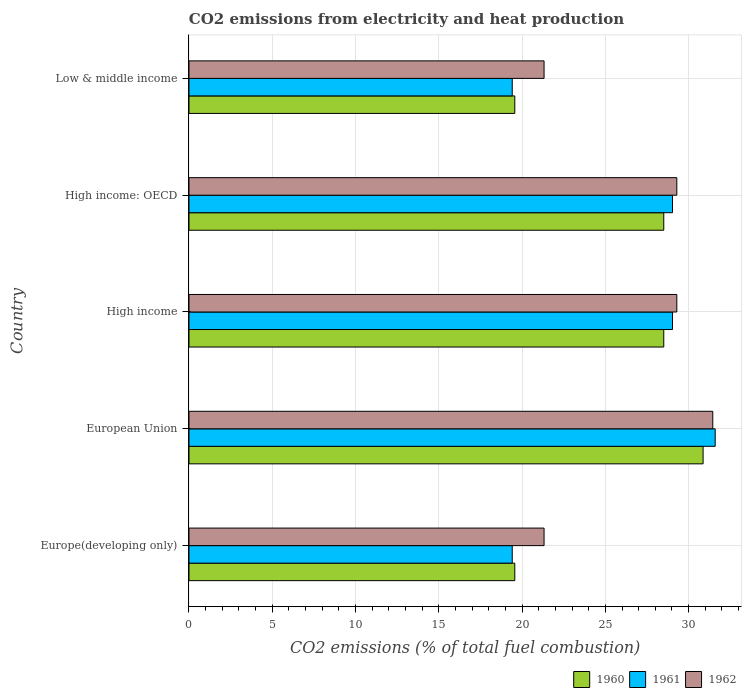How many different coloured bars are there?
Offer a terse response. 3. What is the amount of CO2 emitted in 1961 in Low & middle income?
Ensure brevity in your answer.  19.41. Across all countries, what is the maximum amount of CO2 emitted in 1962?
Ensure brevity in your answer.  31.45. Across all countries, what is the minimum amount of CO2 emitted in 1960?
Make the answer very short. 19.56. In which country was the amount of CO2 emitted in 1961 minimum?
Your answer should be compact. Europe(developing only). What is the total amount of CO2 emitted in 1961 in the graph?
Offer a terse response. 128.48. What is the difference between the amount of CO2 emitted in 1962 in European Union and that in High income: OECD?
Ensure brevity in your answer.  2.16. What is the difference between the amount of CO2 emitted in 1960 in European Union and the amount of CO2 emitted in 1962 in High income?
Offer a terse response. 1.58. What is the average amount of CO2 emitted in 1961 per country?
Your response must be concise. 25.7. What is the difference between the amount of CO2 emitted in 1960 and amount of CO2 emitted in 1962 in High income: OECD?
Make the answer very short. -0.78. What is the ratio of the amount of CO2 emitted in 1962 in European Union to that in High income: OECD?
Your response must be concise. 1.07. What is the difference between the highest and the second highest amount of CO2 emitted in 1960?
Offer a terse response. 2.36. What is the difference between the highest and the lowest amount of CO2 emitted in 1962?
Ensure brevity in your answer.  10.13. Is the sum of the amount of CO2 emitted in 1962 in Europe(developing only) and European Union greater than the maximum amount of CO2 emitted in 1960 across all countries?
Provide a succinct answer. Yes. Is it the case that in every country, the sum of the amount of CO2 emitted in 1962 and amount of CO2 emitted in 1960 is greater than the amount of CO2 emitted in 1961?
Your answer should be very brief. Yes. How many bars are there?
Ensure brevity in your answer.  15. Are all the bars in the graph horizontal?
Provide a short and direct response. Yes. How many countries are there in the graph?
Keep it short and to the point. 5. Does the graph contain any zero values?
Your response must be concise. No. Does the graph contain grids?
Your answer should be very brief. Yes. How are the legend labels stacked?
Ensure brevity in your answer.  Horizontal. What is the title of the graph?
Provide a short and direct response. CO2 emissions from electricity and heat production. Does "1965" appear as one of the legend labels in the graph?
Make the answer very short. No. What is the label or title of the X-axis?
Offer a very short reply. CO2 emissions (% of total fuel combustion). What is the label or title of the Y-axis?
Offer a terse response. Country. What is the CO2 emissions (% of total fuel combustion) of 1960 in Europe(developing only)?
Your response must be concise. 19.56. What is the CO2 emissions (% of total fuel combustion) in 1961 in Europe(developing only)?
Make the answer very short. 19.41. What is the CO2 emissions (% of total fuel combustion) in 1962 in Europe(developing only)?
Your answer should be compact. 21.32. What is the CO2 emissions (% of total fuel combustion) of 1960 in European Union?
Provide a succinct answer. 30.87. What is the CO2 emissions (% of total fuel combustion) in 1961 in European Union?
Your answer should be very brief. 31.59. What is the CO2 emissions (% of total fuel combustion) of 1962 in European Union?
Your answer should be compact. 31.45. What is the CO2 emissions (% of total fuel combustion) in 1960 in High income?
Ensure brevity in your answer.  28.51. What is the CO2 emissions (% of total fuel combustion) in 1961 in High income?
Provide a succinct answer. 29.03. What is the CO2 emissions (% of total fuel combustion) of 1962 in High income?
Provide a succinct answer. 29.29. What is the CO2 emissions (% of total fuel combustion) of 1960 in High income: OECD?
Your answer should be very brief. 28.51. What is the CO2 emissions (% of total fuel combustion) of 1961 in High income: OECD?
Ensure brevity in your answer.  29.03. What is the CO2 emissions (% of total fuel combustion) of 1962 in High income: OECD?
Your answer should be compact. 29.29. What is the CO2 emissions (% of total fuel combustion) of 1960 in Low & middle income?
Your answer should be compact. 19.56. What is the CO2 emissions (% of total fuel combustion) in 1961 in Low & middle income?
Your answer should be very brief. 19.41. What is the CO2 emissions (% of total fuel combustion) in 1962 in Low & middle income?
Your response must be concise. 21.32. Across all countries, what is the maximum CO2 emissions (% of total fuel combustion) in 1960?
Your answer should be compact. 30.87. Across all countries, what is the maximum CO2 emissions (% of total fuel combustion) of 1961?
Offer a very short reply. 31.59. Across all countries, what is the maximum CO2 emissions (% of total fuel combustion) of 1962?
Keep it short and to the point. 31.45. Across all countries, what is the minimum CO2 emissions (% of total fuel combustion) in 1960?
Offer a terse response. 19.56. Across all countries, what is the minimum CO2 emissions (% of total fuel combustion) in 1961?
Provide a succinct answer. 19.41. Across all countries, what is the minimum CO2 emissions (% of total fuel combustion) of 1962?
Your answer should be compact. 21.32. What is the total CO2 emissions (% of total fuel combustion) in 1960 in the graph?
Ensure brevity in your answer.  127.01. What is the total CO2 emissions (% of total fuel combustion) of 1961 in the graph?
Your response must be concise. 128.48. What is the total CO2 emissions (% of total fuel combustion) of 1962 in the graph?
Ensure brevity in your answer.  132.67. What is the difference between the CO2 emissions (% of total fuel combustion) of 1960 in Europe(developing only) and that in European Union?
Your answer should be compact. -11.31. What is the difference between the CO2 emissions (% of total fuel combustion) in 1961 in Europe(developing only) and that in European Union?
Ensure brevity in your answer.  -12.19. What is the difference between the CO2 emissions (% of total fuel combustion) in 1962 in Europe(developing only) and that in European Union?
Offer a terse response. -10.13. What is the difference between the CO2 emissions (% of total fuel combustion) in 1960 in Europe(developing only) and that in High income?
Keep it short and to the point. -8.94. What is the difference between the CO2 emissions (% of total fuel combustion) in 1961 in Europe(developing only) and that in High income?
Offer a terse response. -9.62. What is the difference between the CO2 emissions (% of total fuel combustion) of 1962 in Europe(developing only) and that in High income?
Your answer should be compact. -7.97. What is the difference between the CO2 emissions (% of total fuel combustion) in 1960 in Europe(developing only) and that in High income: OECD?
Ensure brevity in your answer.  -8.94. What is the difference between the CO2 emissions (% of total fuel combustion) in 1961 in Europe(developing only) and that in High income: OECD?
Ensure brevity in your answer.  -9.62. What is the difference between the CO2 emissions (% of total fuel combustion) of 1962 in Europe(developing only) and that in High income: OECD?
Keep it short and to the point. -7.97. What is the difference between the CO2 emissions (% of total fuel combustion) of 1960 in Europe(developing only) and that in Low & middle income?
Offer a very short reply. 0. What is the difference between the CO2 emissions (% of total fuel combustion) of 1961 in Europe(developing only) and that in Low & middle income?
Ensure brevity in your answer.  0. What is the difference between the CO2 emissions (% of total fuel combustion) of 1962 in Europe(developing only) and that in Low & middle income?
Provide a succinct answer. 0. What is the difference between the CO2 emissions (% of total fuel combustion) in 1960 in European Union and that in High income?
Offer a very short reply. 2.36. What is the difference between the CO2 emissions (% of total fuel combustion) in 1961 in European Union and that in High income?
Ensure brevity in your answer.  2.56. What is the difference between the CO2 emissions (% of total fuel combustion) of 1962 in European Union and that in High income?
Make the answer very short. 2.16. What is the difference between the CO2 emissions (% of total fuel combustion) in 1960 in European Union and that in High income: OECD?
Your answer should be very brief. 2.36. What is the difference between the CO2 emissions (% of total fuel combustion) of 1961 in European Union and that in High income: OECD?
Offer a very short reply. 2.56. What is the difference between the CO2 emissions (% of total fuel combustion) in 1962 in European Union and that in High income: OECD?
Offer a terse response. 2.16. What is the difference between the CO2 emissions (% of total fuel combustion) in 1960 in European Union and that in Low & middle income?
Give a very brief answer. 11.31. What is the difference between the CO2 emissions (% of total fuel combustion) in 1961 in European Union and that in Low & middle income?
Your answer should be very brief. 12.19. What is the difference between the CO2 emissions (% of total fuel combustion) of 1962 in European Union and that in Low & middle income?
Offer a very short reply. 10.13. What is the difference between the CO2 emissions (% of total fuel combustion) in 1960 in High income and that in High income: OECD?
Keep it short and to the point. 0. What is the difference between the CO2 emissions (% of total fuel combustion) of 1961 in High income and that in High income: OECD?
Keep it short and to the point. 0. What is the difference between the CO2 emissions (% of total fuel combustion) in 1962 in High income and that in High income: OECD?
Your answer should be compact. 0. What is the difference between the CO2 emissions (% of total fuel combustion) in 1960 in High income and that in Low & middle income?
Your response must be concise. 8.94. What is the difference between the CO2 emissions (% of total fuel combustion) in 1961 in High income and that in Low & middle income?
Your answer should be very brief. 9.62. What is the difference between the CO2 emissions (% of total fuel combustion) of 1962 in High income and that in Low & middle income?
Your answer should be compact. 7.97. What is the difference between the CO2 emissions (% of total fuel combustion) in 1960 in High income: OECD and that in Low & middle income?
Keep it short and to the point. 8.94. What is the difference between the CO2 emissions (% of total fuel combustion) of 1961 in High income: OECD and that in Low & middle income?
Provide a succinct answer. 9.62. What is the difference between the CO2 emissions (% of total fuel combustion) in 1962 in High income: OECD and that in Low & middle income?
Ensure brevity in your answer.  7.97. What is the difference between the CO2 emissions (% of total fuel combustion) of 1960 in Europe(developing only) and the CO2 emissions (% of total fuel combustion) of 1961 in European Union?
Give a very brief answer. -12.03. What is the difference between the CO2 emissions (% of total fuel combustion) of 1960 in Europe(developing only) and the CO2 emissions (% of total fuel combustion) of 1962 in European Union?
Make the answer very short. -11.89. What is the difference between the CO2 emissions (% of total fuel combustion) in 1961 in Europe(developing only) and the CO2 emissions (% of total fuel combustion) in 1962 in European Union?
Offer a terse response. -12.04. What is the difference between the CO2 emissions (% of total fuel combustion) in 1960 in Europe(developing only) and the CO2 emissions (% of total fuel combustion) in 1961 in High income?
Your answer should be compact. -9.47. What is the difference between the CO2 emissions (% of total fuel combustion) in 1960 in Europe(developing only) and the CO2 emissions (% of total fuel combustion) in 1962 in High income?
Keep it short and to the point. -9.73. What is the difference between the CO2 emissions (% of total fuel combustion) of 1961 in Europe(developing only) and the CO2 emissions (% of total fuel combustion) of 1962 in High income?
Ensure brevity in your answer.  -9.88. What is the difference between the CO2 emissions (% of total fuel combustion) of 1960 in Europe(developing only) and the CO2 emissions (% of total fuel combustion) of 1961 in High income: OECD?
Offer a very short reply. -9.47. What is the difference between the CO2 emissions (% of total fuel combustion) of 1960 in Europe(developing only) and the CO2 emissions (% of total fuel combustion) of 1962 in High income: OECD?
Offer a terse response. -9.73. What is the difference between the CO2 emissions (% of total fuel combustion) in 1961 in Europe(developing only) and the CO2 emissions (% of total fuel combustion) in 1962 in High income: OECD?
Make the answer very short. -9.88. What is the difference between the CO2 emissions (% of total fuel combustion) in 1960 in Europe(developing only) and the CO2 emissions (% of total fuel combustion) in 1961 in Low & middle income?
Make the answer very short. 0.15. What is the difference between the CO2 emissions (% of total fuel combustion) in 1960 in Europe(developing only) and the CO2 emissions (% of total fuel combustion) in 1962 in Low & middle income?
Your answer should be very brief. -1.76. What is the difference between the CO2 emissions (% of total fuel combustion) of 1961 in Europe(developing only) and the CO2 emissions (% of total fuel combustion) of 1962 in Low & middle income?
Offer a terse response. -1.91. What is the difference between the CO2 emissions (% of total fuel combustion) of 1960 in European Union and the CO2 emissions (% of total fuel combustion) of 1961 in High income?
Give a very brief answer. 1.84. What is the difference between the CO2 emissions (% of total fuel combustion) of 1960 in European Union and the CO2 emissions (% of total fuel combustion) of 1962 in High income?
Your answer should be compact. 1.58. What is the difference between the CO2 emissions (% of total fuel combustion) in 1961 in European Union and the CO2 emissions (% of total fuel combustion) in 1962 in High income?
Your answer should be very brief. 2.3. What is the difference between the CO2 emissions (% of total fuel combustion) of 1960 in European Union and the CO2 emissions (% of total fuel combustion) of 1961 in High income: OECD?
Offer a very short reply. 1.84. What is the difference between the CO2 emissions (% of total fuel combustion) in 1960 in European Union and the CO2 emissions (% of total fuel combustion) in 1962 in High income: OECD?
Give a very brief answer. 1.58. What is the difference between the CO2 emissions (% of total fuel combustion) of 1961 in European Union and the CO2 emissions (% of total fuel combustion) of 1962 in High income: OECD?
Provide a succinct answer. 2.3. What is the difference between the CO2 emissions (% of total fuel combustion) of 1960 in European Union and the CO2 emissions (% of total fuel combustion) of 1961 in Low & middle income?
Offer a terse response. 11.46. What is the difference between the CO2 emissions (% of total fuel combustion) in 1960 in European Union and the CO2 emissions (% of total fuel combustion) in 1962 in Low & middle income?
Ensure brevity in your answer.  9.55. What is the difference between the CO2 emissions (% of total fuel combustion) in 1961 in European Union and the CO2 emissions (% of total fuel combustion) in 1962 in Low & middle income?
Provide a short and direct response. 10.27. What is the difference between the CO2 emissions (% of total fuel combustion) of 1960 in High income and the CO2 emissions (% of total fuel combustion) of 1961 in High income: OECD?
Offer a very short reply. -0.53. What is the difference between the CO2 emissions (% of total fuel combustion) in 1960 in High income and the CO2 emissions (% of total fuel combustion) in 1962 in High income: OECD?
Keep it short and to the point. -0.78. What is the difference between the CO2 emissions (% of total fuel combustion) in 1961 in High income and the CO2 emissions (% of total fuel combustion) in 1962 in High income: OECD?
Your answer should be compact. -0.26. What is the difference between the CO2 emissions (% of total fuel combustion) in 1960 in High income and the CO2 emissions (% of total fuel combustion) in 1961 in Low & middle income?
Your response must be concise. 9.1. What is the difference between the CO2 emissions (% of total fuel combustion) of 1960 in High income and the CO2 emissions (% of total fuel combustion) of 1962 in Low & middle income?
Provide a succinct answer. 7.19. What is the difference between the CO2 emissions (% of total fuel combustion) of 1961 in High income and the CO2 emissions (% of total fuel combustion) of 1962 in Low & middle income?
Give a very brief answer. 7.71. What is the difference between the CO2 emissions (% of total fuel combustion) in 1960 in High income: OECD and the CO2 emissions (% of total fuel combustion) in 1961 in Low & middle income?
Your answer should be very brief. 9.1. What is the difference between the CO2 emissions (% of total fuel combustion) in 1960 in High income: OECD and the CO2 emissions (% of total fuel combustion) in 1962 in Low & middle income?
Your answer should be very brief. 7.19. What is the difference between the CO2 emissions (% of total fuel combustion) of 1961 in High income: OECD and the CO2 emissions (% of total fuel combustion) of 1962 in Low & middle income?
Your answer should be compact. 7.71. What is the average CO2 emissions (% of total fuel combustion) in 1960 per country?
Provide a short and direct response. 25.4. What is the average CO2 emissions (% of total fuel combustion) of 1961 per country?
Your answer should be very brief. 25.7. What is the average CO2 emissions (% of total fuel combustion) in 1962 per country?
Ensure brevity in your answer.  26.53. What is the difference between the CO2 emissions (% of total fuel combustion) of 1960 and CO2 emissions (% of total fuel combustion) of 1961 in Europe(developing only)?
Give a very brief answer. 0.15. What is the difference between the CO2 emissions (% of total fuel combustion) in 1960 and CO2 emissions (% of total fuel combustion) in 1962 in Europe(developing only)?
Provide a short and direct response. -1.76. What is the difference between the CO2 emissions (% of total fuel combustion) of 1961 and CO2 emissions (% of total fuel combustion) of 1962 in Europe(developing only)?
Provide a succinct answer. -1.91. What is the difference between the CO2 emissions (% of total fuel combustion) in 1960 and CO2 emissions (% of total fuel combustion) in 1961 in European Union?
Offer a very short reply. -0.73. What is the difference between the CO2 emissions (% of total fuel combustion) of 1960 and CO2 emissions (% of total fuel combustion) of 1962 in European Union?
Your answer should be compact. -0.58. What is the difference between the CO2 emissions (% of total fuel combustion) of 1961 and CO2 emissions (% of total fuel combustion) of 1962 in European Union?
Provide a succinct answer. 0.14. What is the difference between the CO2 emissions (% of total fuel combustion) of 1960 and CO2 emissions (% of total fuel combustion) of 1961 in High income?
Make the answer very short. -0.53. What is the difference between the CO2 emissions (% of total fuel combustion) of 1960 and CO2 emissions (% of total fuel combustion) of 1962 in High income?
Your answer should be very brief. -0.78. What is the difference between the CO2 emissions (% of total fuel combustion) in 1961 and CO2 emissions (% of total fuel combustion) in 1962 in High income?
Make the answer very short. -0.26. What is the difference between the CO2 emissions (% of total fuel combustion) of 1960 and CO2 emissions (% of total fuel combustion) of 1961 in High income: OECD?
Your answer should be very brief. -0.53. What is the difference between the CO2 emissions (% of total fuel combustion) in 1960 and CO2 emissions (% of total fuel combustion) in 1962 in High income: OECD?
Keep it short and to the point. -0.78. What is the difference between the CO2 emissions (% of total fuel combustion) in 1961 and CO2 emissions (% of total fuel combustion) in 1962 in High income: OECD?
Ensure brevity in your answer.  -0.26. What is the difference between the CO2 emissions (% of total fuel combustion) in 1960 and CO2 emissions (% of total fuel combustion) in 1961 in Low & middle income?
Keep it short and to the point. 0.15. What is the difference between the CO2 emissions (% of total fuel combustion) of 1960 and CO2 emissions (% of total fuel combustion) of 1962 in Low & middle income?
Keep it short and to the point. -1.76. What is the difference between the CO2 emissions (% of total fuel combustion) in 1961 and CO2 emissions (% of total fuel combustion) in 1962 in Low & middle income?
Make the answer very short. -1.91. What is the ratio of the CO2 emissions (% of total fuel combustion) in 1960 in Europe(developing only) to that in European Union?
Offer a terse response. 0.63. What is the ratio of the CO2 emissions (% of total fuel combustion) of 1961 in Europe(developing only) to that in European Union?
Provide a short and direct response. 0.61. What is the ratio of the CO2 emissions (% of total fuel combustion) of 1962 in Europe(developing only) to that in European Union?
Provide a short and direct response. 0.68. What is the ratio of the CO2 emissions (% of total fuel combustion) of 1960 in Europe(developing only) to that in High income?
Make the answer very short. 0.69. What is the ratio of the CO2 emissions (% of total fuel combustion) of 1961 in Europe(developing only) to that in High income?
Your response must be concise. 0.67. What is the ratio of the CO2 emissions (% of total fuel combustion) of 1962 in Europe(developing only) to that in High income?
Your answer should be compact. 0.73. What is the ratio of the CO2 emissions (% of total fuel combustion) in 1960 in Europe(developing only) to that in High income: OECD?
Your answer should be compact. 0.69. What is the ratio of the CO2 emissions (% of total fuel combustion) in 1961 in Europe(developing only) to that in High income: OECD?
Ensure brevity in your answer.  0.67. What is the ratio of the CO2 emissions (% of total fuel combustion) of 1962 in Europe(developing only) to that in High income: OECD?
Your response must be concise. 0.73. What is the ratio of the CO2 emissions (% of total fuel combustion) in 1962 in Europe(developing only) to that in Low & middle income?
Provide a short and direct response. 1. What is the ratio of the CO2 emissions (% of total fuel combustion) of 1960 in European Union to that in High income?
Keep it short and to the point. 1.08. What is the ratio of the CO2 emissions (% of total fuel combustion) of 1961 in European Union to that in High income?
Give a very brief answer. 1.09. What is the ratio of the CO2 emissions (% of total fuel combustion) of 1962 in European Union to that in High income?
Your answer should be very brief. 1.07. What is the ratio of the CO2 emissions (% of total fuel combustion) of 1960 in European Union to that in High income: OECD?
Give a very brief answer. 1.08. What is the ratio of the CO2 emissions (% of total fuel combustion) in 1961 in European Union to that in High income: OECD?
Your response must be concise. 1.09. What is the ratio of the CO2 emissions (% of total fuel combustion) of 1962 in European Union to that in High income: OECD?
Give a very brief answer. 1.07. What is the ratio of the CO2 emissions (% of total fuel combustion) of 1960 in European Union to that in Low & middle income?
Your answer should be compact. 1.58. What is the ratio of the CO2 emissions (% of total fuel combustion) in 1961 in European Union to that in Low & middle income?
Offer a very short reply. 1.63. What is the ratio of the CO2 emissions (% of total fuel combustion) of 1962 in European Union to that in Low & middle income?
Your answer should be compact. 1.48. What is the ratio of the CO2 emissions (% of total fuel combustion) of 1960 in High income to that in High income: OECD?
Keep it short and to the point. 1. What is the ratio of the CO2 emissions (% of total fuel combustion) in 1960 in High income to that in Low & middle income?
Offer a terse response. 1.46. What is the ratio of the CO2 emissions (% of total fuel combustion) of 1961 in High income to that in Low & middle income?
Your response must be concise. 1.5. What is the ratio of the CO2 emissions (% of total fuel combustion) of 1962 in High income to that in Low & middle income?
Your answer should be very brief. 1.37. What is the ratio of the CO2 emissions (% of total fuel combustion) in 1960 in High income: OECD to that in Low & middle income?
Make the answer very short. 1.46. What is the ratio of the CO2 emissions (% of total fuel combustion) in 1961 in High income: OECD to that in Low & middle income?
Provide a succinct answer. 1.5. What is the ratio of the CO2 emissions (% of total fuel combustion) of 1962 in High income: OECD to that in Low & middle income?
Provide a short and direct response. 1.37. What is the difference between the highest and the second highest CO2 emissions (% of total fuel combustion) of 1960?
Make the answer very short. 2.36. What is the difference between the highest and the second highest CO2 emissions (% of total fuel combustion) of 1961?
Your answer should be compact. 2.56. What is the difference between the highest and the second highest CO2 emissions (% of total fuel combustion) of 1962?
Your answer should be compact. 2.16. What is the difference between the highest and the lowest CO2 emissions (% of total fuel combustion) in 1960?
Keep it short and to the point. 11.31. What is the difference between the highest and the lowest CO2 emissions (% of total fuel combustion) of 1961?
Offer a terse response. 12.19. What is the difference between the highest and the lowest CO2 emissions (% of total fuel combustion) of 1962?
Your answer should be very brief. 10.13. 